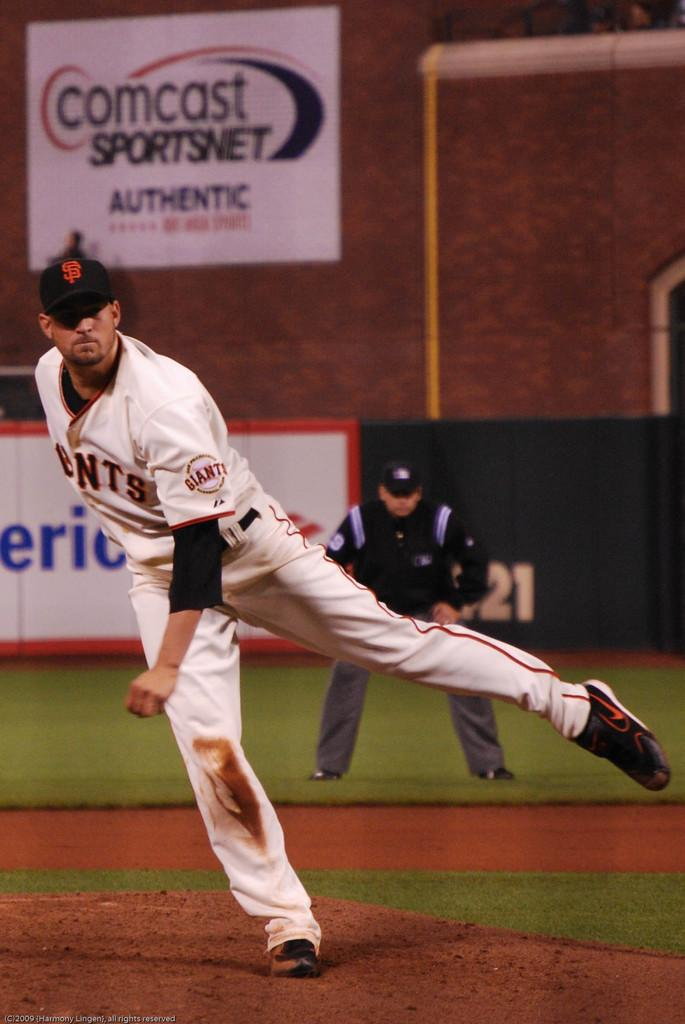Provide a one-sentence caption for the provided image. A baseball player playing near a  large Comcast poster. 